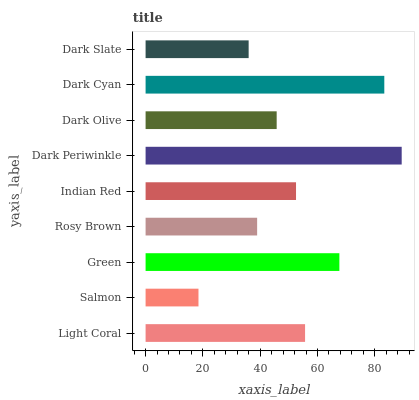Is Salmon the minimum?
Answer yes or no. Yes. Is Dark Periwinkle the maximum?
Answer yes or no. Yes. Is Green the minimum?
Answer yes or no. No. Is Green the maximum?
Answer yes or no. No. Is Green greater than Salmon?
Answer yes or no. Yes. Is Salmon less than Green?
Answer yes or no. Yes. Is Salmon greater than Green?
Answer yes or no. No. Is Green less than Salmon?
Answer yes or no. No. Is Indian Red the high median?
Answer yes or no. Yes. Is Indian Red the low median?
Answer yes or no. Yes. Is Green the high median?
Answer yes or no. No. Is Salmon the low median?
Answer yes or no. No. 